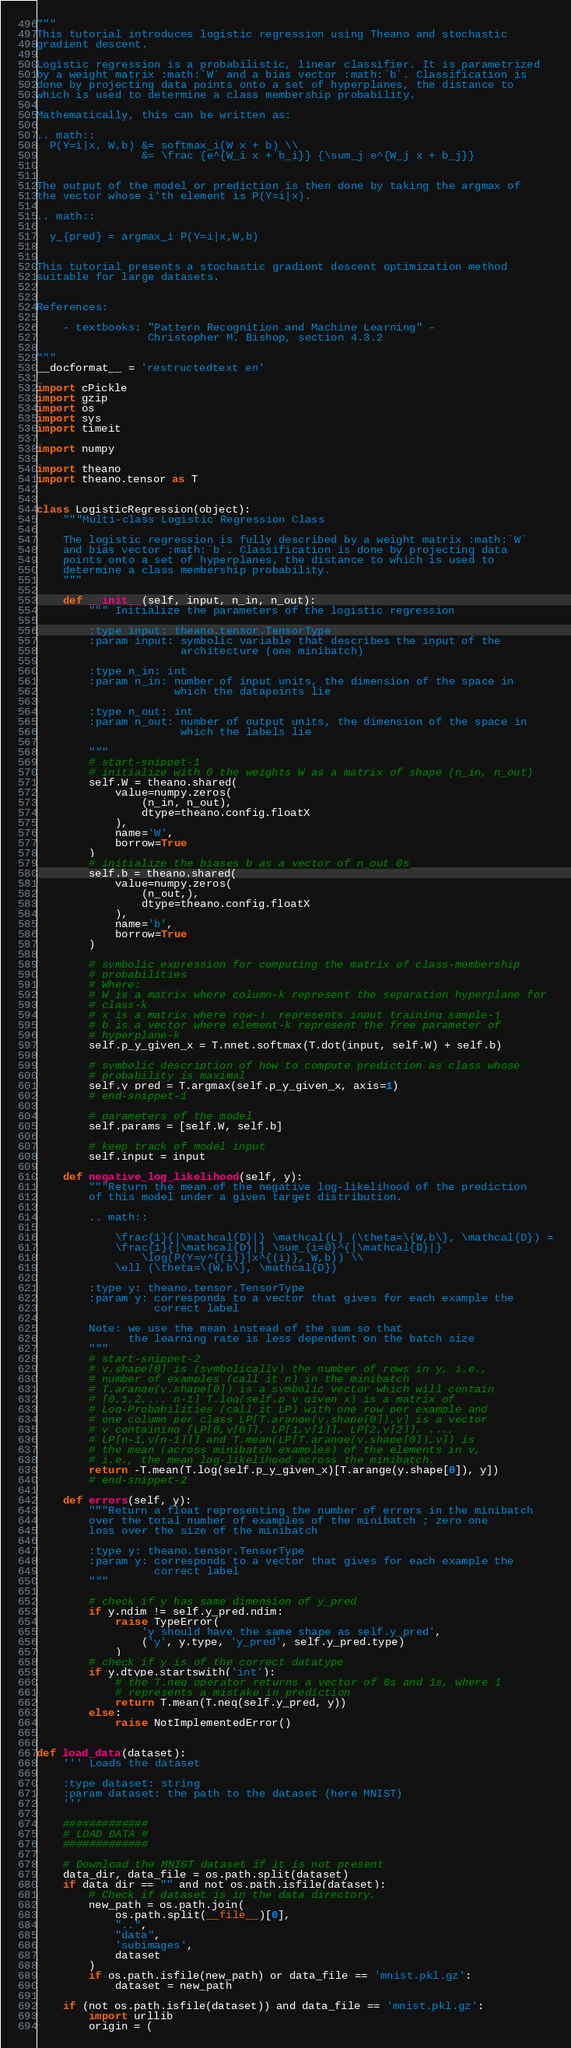Convert code to text. <code><loc_0><loc_0><loc_500><loc_500><_Python_>"""
This tutorial introduces logistic regression using Theano and stochastic
gradient descent.

Logistic regression is a probabilistic, linear classifier. It is parametrized
by a weight matrix :math:`W` and a bias vector :math:`b`. Classification is
done by projecting data points onto a set of hyperplanes, the distance to
which is used to determine a class membership probability.

Mathematically, this can be written as:

.. math::
  P(Y=i|x, W,b) &= softmax_i(W x + b) \\
                &= \frac {e^{W_i x + b_i}} {\sum_j e^{W_j x + b_j}}


The output of the model or prediction is then done by taking the argmax of
the vector whose i'th element is P(Y=i|x).

.. math::

  y_{pred} = argmax_i P(Y=i|x,W,b)


This tutorial presents a stochastic gradient descent optimization method
suitable for large datasets.


References:

    - textbooks: "Pattern Recognition and Machine Learning" -
                 Christopher M. Bishop, section 4.3.2

"""
__docformat__ = 'restructedtext en'

import cPickle
import gzip
import os
import sys
import timeit

import numpy

import theano
import theano.tensor as T


class LogisticRegression(object):
    """Multi-class Logistic Regression Class

    The logistic regression is fully described by a weight matrix :math:`W`
    and bias vector :math:`b`. Classification is done by projecting data
    points onto a set of hyperplanes, the distance to which is used to
    determine a class membership probability.
    """

    def __init__(self, input, n_in, n_out):
        """ Initialize the parameters of the logistic regression

        :type input: theano.tensor.TensorType
        :param input: symbolic variable that describes the input of the
                      architecture (one minibatch)

        :type n_in: int
        :param n_in: number of input units, the dimension of the space in
                     which the datapoints lie

        :type n_out: int
        :param n_out: number of output units, the dimension of the space in
                      which the labels lie

        """
        # start-snippet-1
        # initialize with 0 the weights W as a matrix of shape (n_in, n_out)
        self.W = theano.shared(
            value=numpy.zeros(
                (n_in, n_out),
                dtype=theano.config.floatX
            ),
            name='W',
            borrow=True
        )
        # initialize the biases b as a vector of n_out 0s
        self.b = theano.shared(
            value=numpy.zeros(
                (n_out,),
                dtype=theano.config.floatX
            ),
            name='b',
            borrow=True
        )

        # symbolic expression for computing the matrix of class-membership
        # probabilities
        # Where:
        # W is a matrix where column-k represent the separation hyperplane for
        # class-k
        # x is a matrix where row-j  represents input training sample-j
        # b is a vector where element-k represent the free parameter of
        # hyperplane-k
        self.p_y_given_x = T.nnet.softmax(T.dot(input, self.W) + self.b)

        # symbolic description of how to compute prediction as class whose
        # probability is maximal
        self.y_pred = T.argmax(self.p_y_given_x, axis=1)
        # end-snippet-1

        # parameters of the model
        self.params = [self.W, self.b]

        # keep track of model input
        self.input = input

    def negative_log_likelihood(self, y):
        """Return the mean of the negative log-likelihood of the prediction
        of this model under a given target distribution.

        .. math::

            \frac{1}{|\mathcal{D}|} \mathcal{L} (\theta=\{W,b\}, \mathcal{D}) =
            \frac{1}{|\mathcal{D}|} \sum_{i=0}^{|\mathcal{D}|}
                \log(P(Y=y^{(i)}|x^{(i)}, W,b)) \\
            \ell (\theta=\{W,b\}, \mathcal{D})

        :type y: theano.tensor.TensorType
        :param y: corresponds to a vector that gives for each example the
                  correct label

        Note: we use the mean instead of the sum so that
              the learning rate is less dependent on the batch size
        """
        # start-snippet-2
        # y.shape[0] is (symbolically) the number of rows in y, i.e.,
        # number of examples (call it n) in the minibatch
        # T.arange(y.shape[0]) is a symbolic vector which will contain
        # [0,1,2,... n-1] T.log(self.p_y_given_x) is a matrix of
        # Log-Probabilities (call it LP) with one row per example and
        # one column per class LP[T.arange(y.shape[0]),y] is a vector
        # v containing [LP[0,y[0]], LP[1,y[1]], LP[2,y[2]], ...,
        # LP[n-1,y[n-1]]] and T.mean(LP[T.arange(y.shape[0]),y]) is
        # the mean (across minibatch examples) of the elements in v,
        # i.e., the mean log-likelihood across the minibatch.
        return -T.mean(T.log(self.p_y_given_x)[T.arange(y.shape[0]), y])
        # end-snippet-2

    def errors(self, y):
        """Return a float representing the number of errors in the minibatch
        over the total number of examples of the minibatch ; zero one
        loss over the size of the minibatch

        :type y: theano.tensor.TensorType
        :param y: corresponds to a vector that gives for each example the
                  correct label
        """

        # check if y has same dimension of y_pred
        if y.ndim != self.y_pred.ndim:
            raise TypeError(
                'y should have the same shape as self.y_pred',
                ('y', y.type, 'y_pred', self.y_pred.type)
            )
        # check if y is of the correct datatype
        if y.dtype.startswith('int'):
            # the T.neq operator returns a vector of 0s and 1s, where 1
            # represents a mistake in prediction
            return T.mean(T.neq(self.y_pred, y))
        else:
            raise NotImplementedError()


def load_data(dataset):
    ''' Loads the dataset

    :type dataset: string
    :param dataset: the path to the dataset (here MNIST)
    '''

    #############
    # LOAD DATA #
    #############

    # Download the MNIST dataset if it is not present
    data_dir, data_file = os.path.split(dataset)
    if data_dir == "" and not os.path.isfile(dataset):
        # Check if dataset is in the data directory.
        new_path = os.path.join(
            os.path.split(__file__)[0],
            "..",
            "data",
            'subimages',
            dataset
        )
        if os.path.isfile(new_path) or data_file == 'mnist.pkl.gz':
            dataset = new_path

    if (not os.path.isfile(dataset)) and data_file == 'mnist.pkl.gz':
        import urllib
        origin = (</code> 